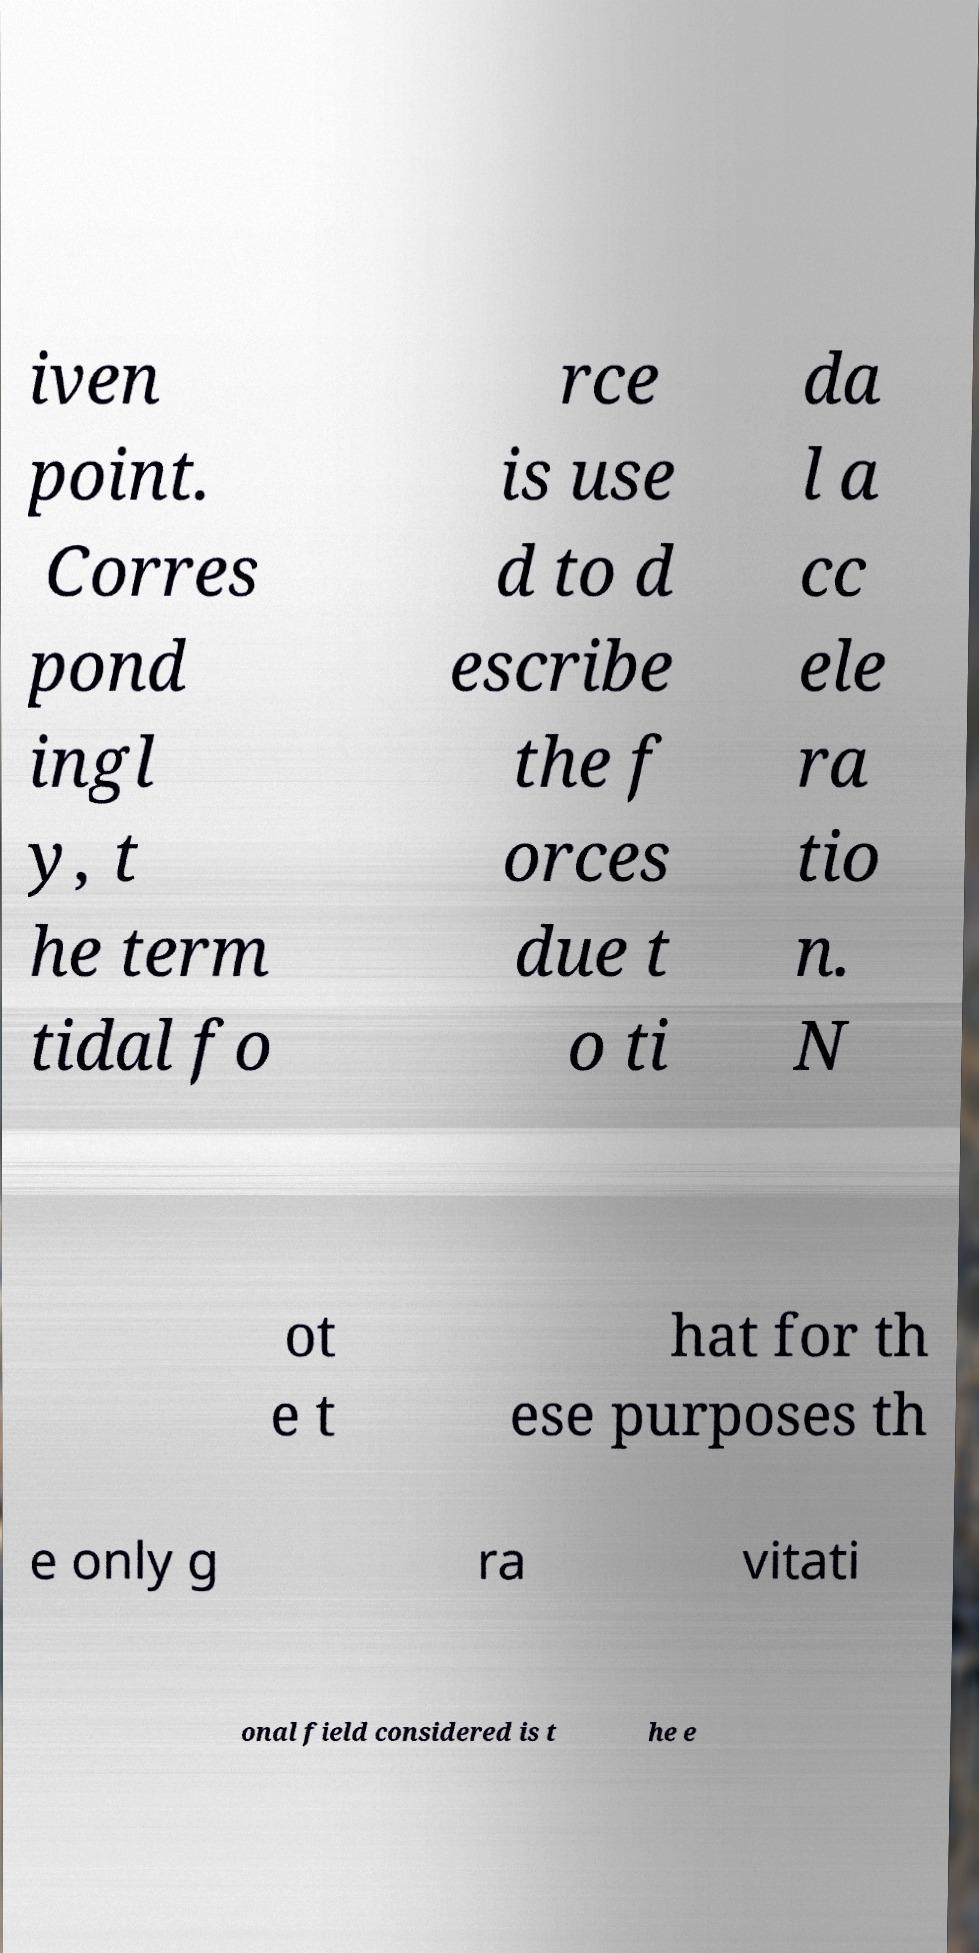I need the written content from this picture converted into text. Can you do that? iven point. Corres pond ingl y, t he term tidal fo rce is use d to d escribe the f orces due t o ti da l a cc ele ra tio n. N ot e t hat for th ese purposes th e only g ra vitati onal field considered is t he e 